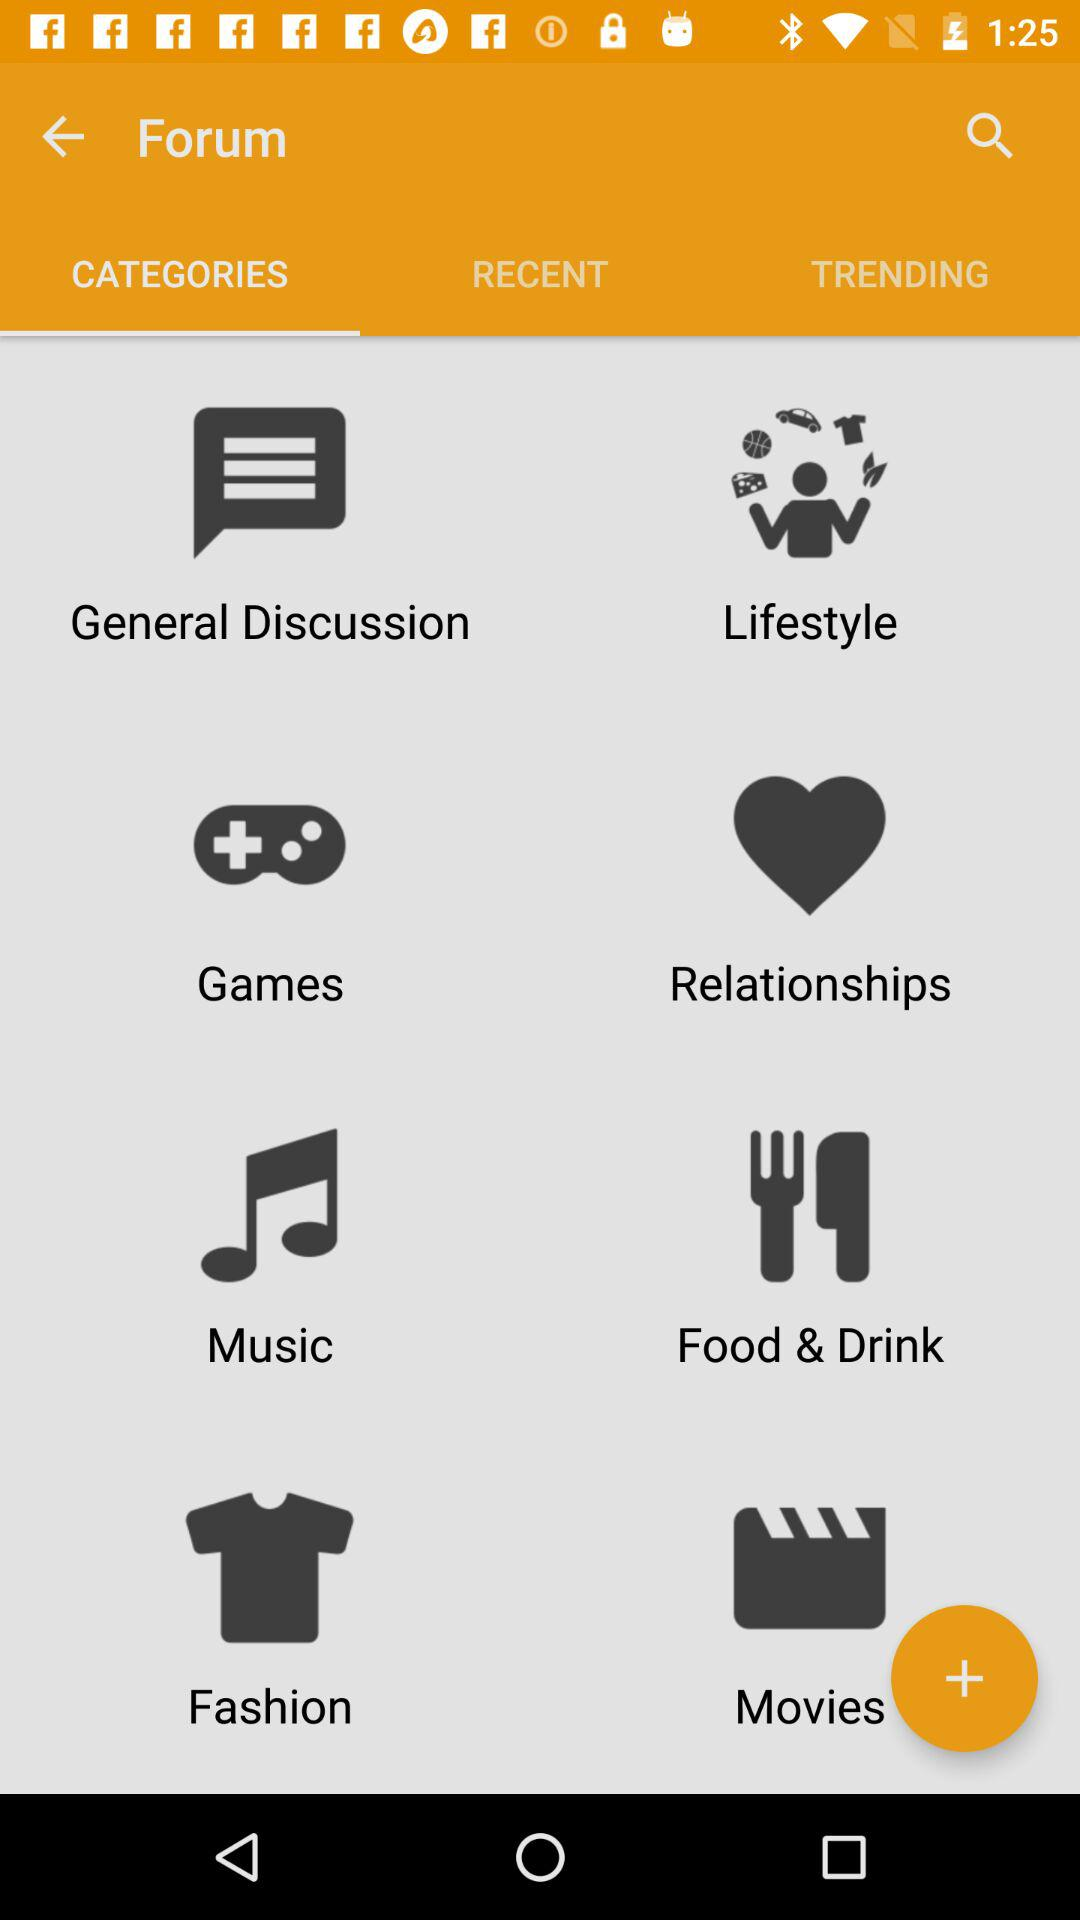What are the various categories displayed in the "Forum"? The various categories displayed in the "Forum" are "General Discussion", "Lifestyle", "Games", "Relationships", "Music", "Food & Drink", "Fashion" and "Movies". 